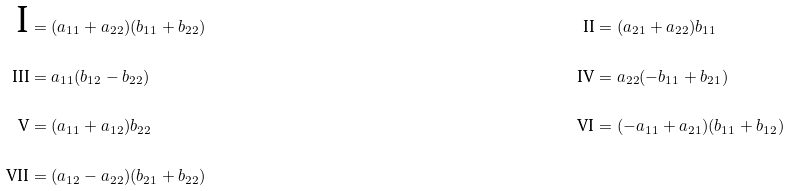Convert formula to latex. <formula><loc_0><loc_0><loc_500><loc_500>\text {I} & = ( a _ { 1 1 } + a _ { 2 2 } ) ( b _ { 1 1 } + b _ { 2 2 } ) & \text {II} & = ( a _ { 2 1 } + a _ { 2 2 } ) b _ { 1 1 } \\ \text {III} & = a _ { 1 1 } ( b _ { 1 2 } - b _ { 2 2 } ) & \text {IV} & = a _ { 2 2 } ( - b _ { 1 1 } + b _ { 2 1 } ) \\ \text {V} & = ( a _ { 1 1 } + a _ { 1 2 } ) b _ { 2 2 } & \text {VI} & = ( - a _ { 1 1 } + a _ { 2 1 } ) ( b _ { 1 1 } + b _ { 1 2 } ) \\ \text {VII} & = ( a _ { 1 2 } - a _ { 2 2 } ) ( b _ { 2 1 } + b _ { 2 2 } )</formula> 